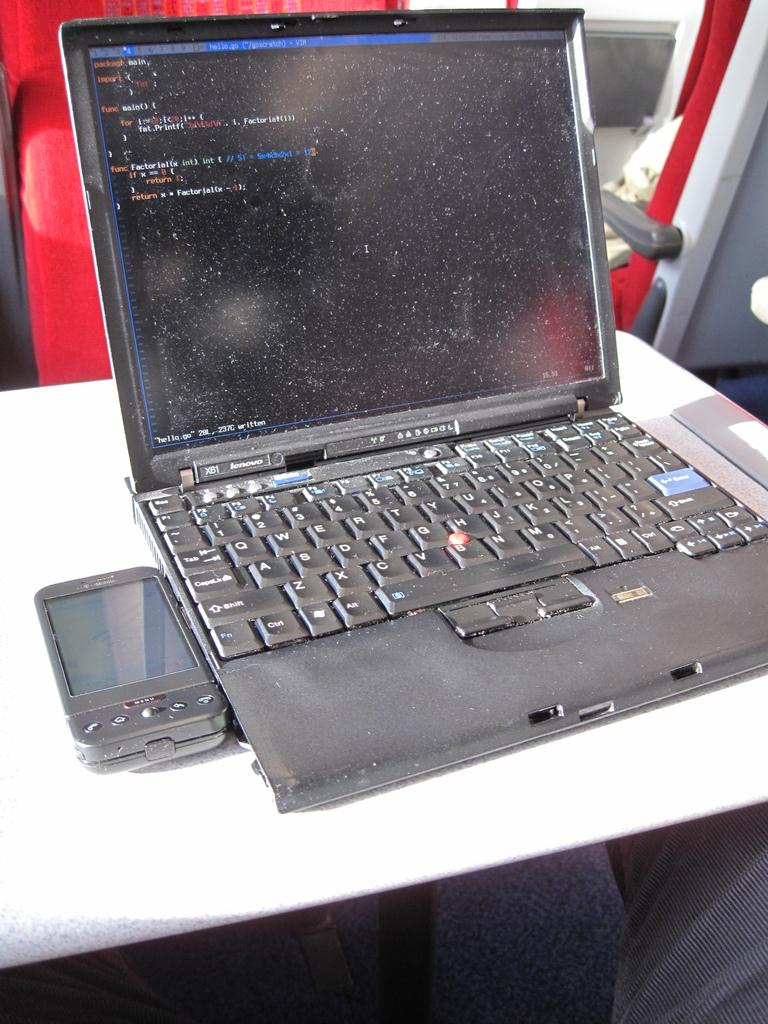<image>
Give a short and clear explanation of the subsequent image. The old laptop computer is an XB1 Lenovo computer. 